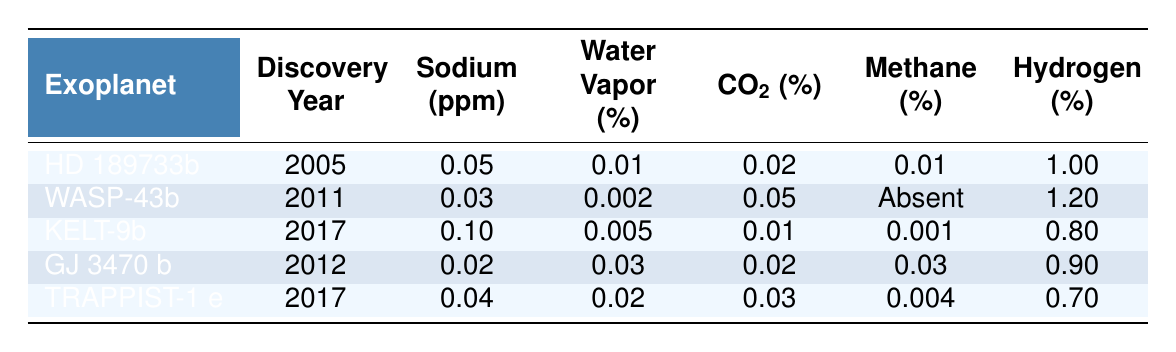What is the atmospheric composition of HD 189733b in terms of sodium? According to the table, HD 189733b has a sodium level of 0.05 ppm.
Answer: 0.05 ppm Which exoplanet was discovered in 2012? The table shows that GJ 3470 b was discovered in 2012.
Answer: GJ 3470 b What is the average hydrogen percentage across the five exoplanets listed? To find the average hydrogen percentage, we first sum the values: 1.00 + 1.20 + 0.80 + 0.90 + 0.70 = 4.60. There are 5 exoplanets, so the average is 4.60 / 5 = 0.92.
Answer: 0.92% Is methane present in the atmosphere of WASP-43b? The table indicates that methane is marked as "Absent" for WASP-43b.
Answer: No Which exoplanet has the highest sodium concentration? By examining the sodium concentrations listed in the table, KELT-9b has the highest concentration at 0.10 ppm.
Answer: KELT-9b If we compare the water vapor percentages of HD 189733b and TRAPPIST-1 e, which has more? HD 189733b has 0.01% water vapor, while TRAPPIST-1 e has 0.02%. Since 0.02% is greater than 0.01%, TRAPPIST-1 e has more water vapor.
Answer: TRAPPIST-1 e What component is missing from the atmospheric composition of WASP-43b? According to the table, methane is absent from the atmospheric composition of WASP-43b.
Answer: Methane How does the discovery year of KELT-9b compare to GJ 3470 b? KELT-9b was discovered in 2017, while GJ 3470 b was discovered in 2012. Therefore, KELT-9b was discovered 5 years later than GJ 3470 b.
Answer: 5 years later Which exoplanet has the most diverse atmospheric composition based on the unique components listed? By observing the atmospheric components of each exoplanet, HD 189733b, GJ 3470 b, and TRAPPIST-1 e all have four components present. However, WASP-43b has three, and KELT-9b has four as well. Since multiple exoplanets share the highest diversity, no single answer can be given.
Answer: No single exoplanet 